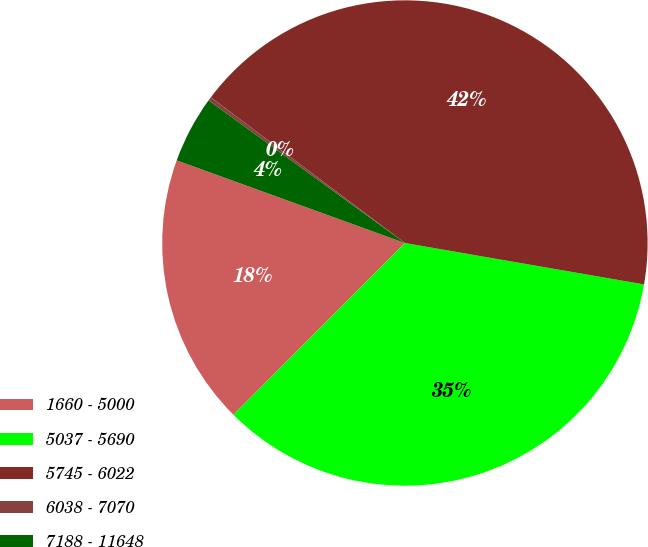Convert chart to OTSL. <chart><loc_0><loc_0><loc_500><loc_500><pie_chart><fcel>1660 - 5000<fcel>5037 - 5690<fcel>5745 - 6022<fcel>6038 - 7070<fcel>7188 - 11648<nl><fcel>18.04%<fcel>34.76%<fcel>42.48%<fcel>0.25%<fcel>4.47%<nl></chart> 